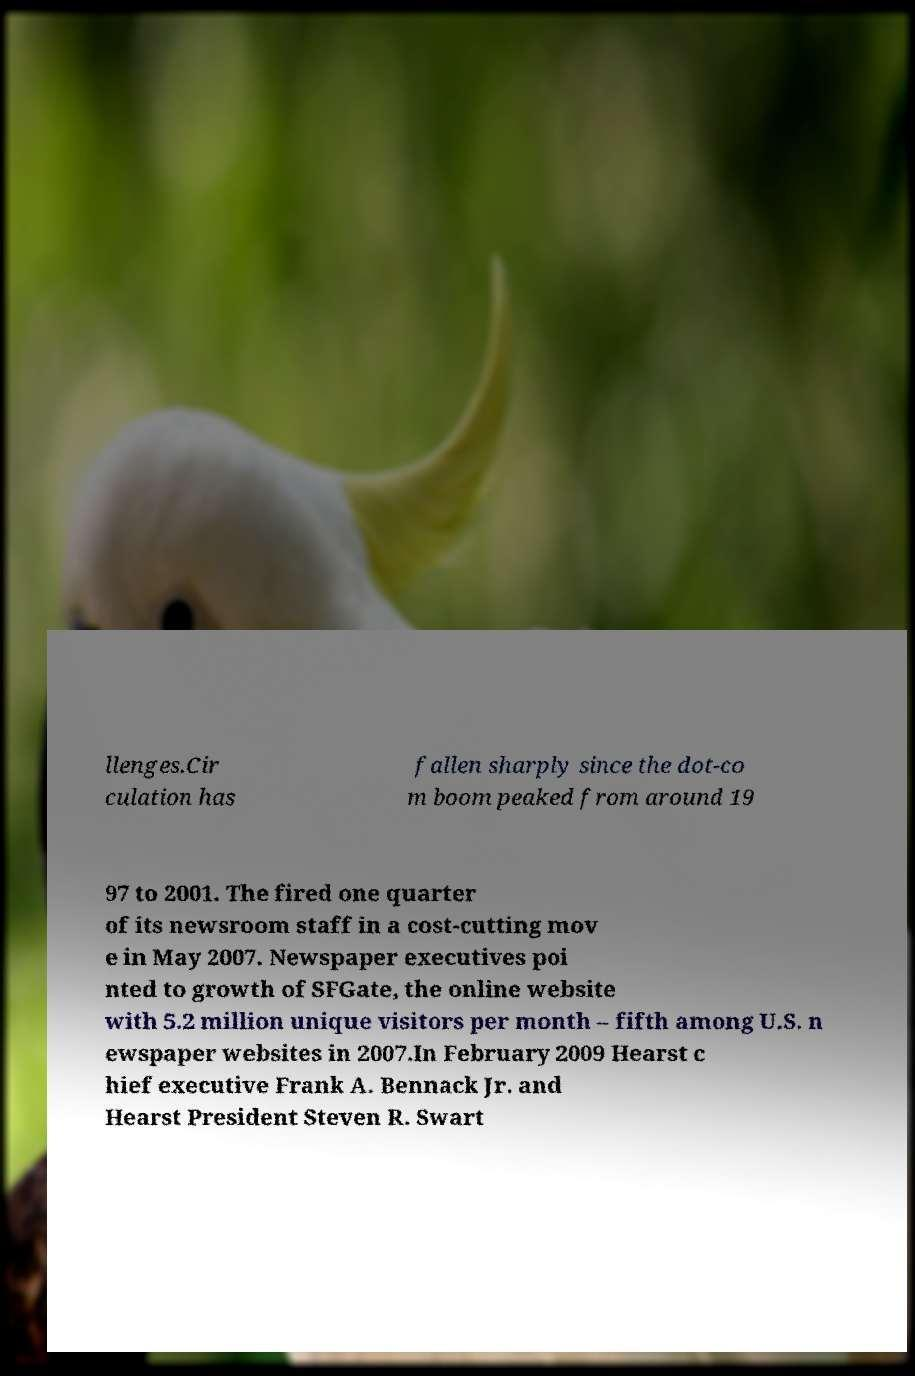There's text embedded in this image that I need extracted. Can you transcribe it verbatim? llenges.Cir culation has fallen sharply since the dot-co m boom peaked from around 19 97 to 2001. The fired one quarter of its newsroom staff in a cost-cutting mov e in May 2007. Newspaper executives poi nted to growth of SFGate, the online website with 5.2 million unique visitors per month – fifth among U.S. n ewspaper websites in 2007.In February 2009 Hearst c hief executive Frank A. Bennack Jr. and Hearst President Steven R. Swart 